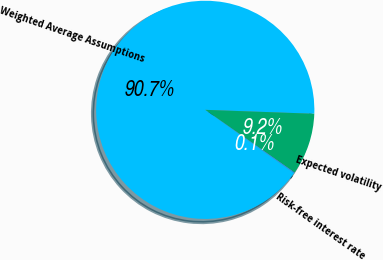Convert chart. <chart><loc_0><loc_0><loc_500><loc_500><pie_chart><fcel>Weighted Average Assumptions<fcel>Expected volatility<fcel>Risk-free interest rate<nl><fcel>90.72%<fcel>9.17%<fcel>0.11%<nl></chart> 